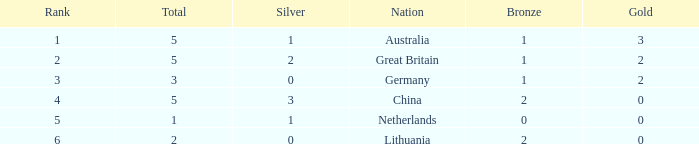What is the median gold when the rank is lesser than 3 and the bronze is lesser than 1? None. 